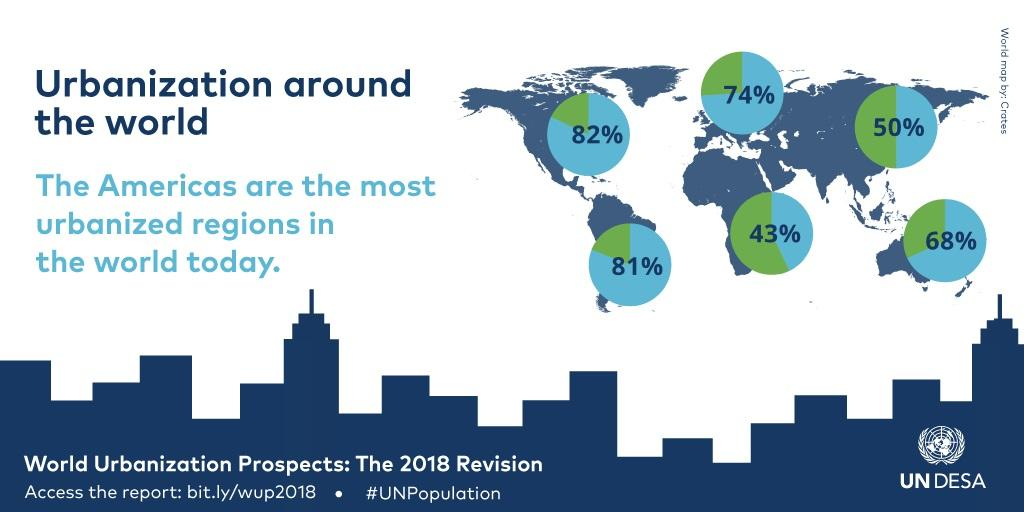Give some essential details in this illustration. The difference in percentage between North America and South America is 1%. The difference in percentage between North America and Australia is 14%. 